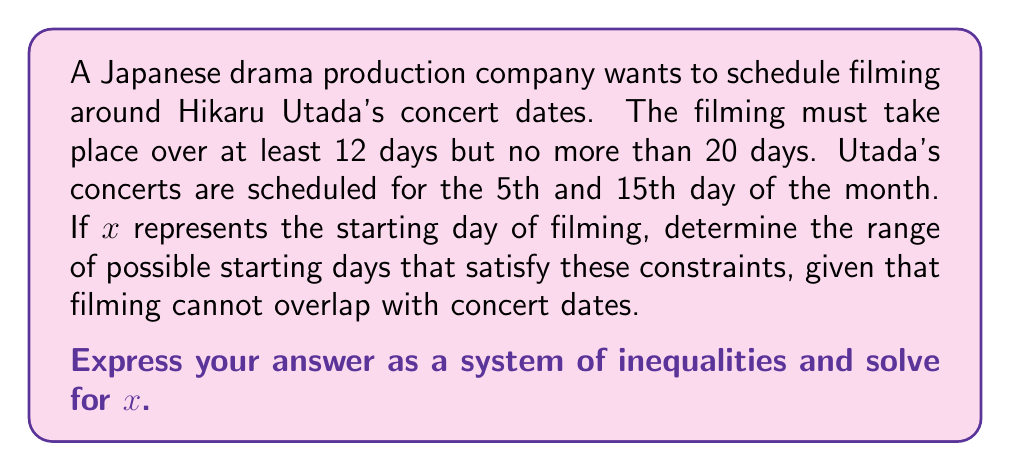Give your solution to this math problem. Let's approach this step-by-step:

1) Let x be the starting day of filming.

2) The filming duration must be at least 12 days and at most 20 days. This gives us:
   $$ 12 \leq \text{filming duration} \leq 20 $$

3) The filming cannot overlap with the concert dates (5th and 15th day). This means:
   - Filming must end before the 5th day, OR
   - Filming must start after the 5th day and end before the 15th day, OR
   - Filming must start after the 15th day

4) Let's express these conditions mathematically:
   $$ (x + 11 < 5) \text{ OR } (5 < x \text{ AND } x + 11 < 15) \text{ OR } (15 < x) $$

5) Simplifying:
   $$ (x < -6) \text{ OR } (5 < x < 4) \text{ OR } (15 < x) $$

6) The second condition $(5 < x < 4)$ is impossible, so we can discard it.

7) Combining with the duration constraint:
   $$ (x < -6) \text{ OR } (15 < x \leq 20 - 12 + 1) $$
   $$ (x < -6) \text{ OR } (15 < x \leq 9) $$

8) The condition $(x < -6)$ is not relevant as we can't start filming before the 1st day of the month.

9) Therefore, our final system of inequalities is:
   $$ 15 < x \leq 9 $$

10) However, x must be an integer (as we're dealing with days). So the final solution is:
    $$ 16 \leq x \leq 9 $$
Answer: $16 \leq x \leq 9$ 